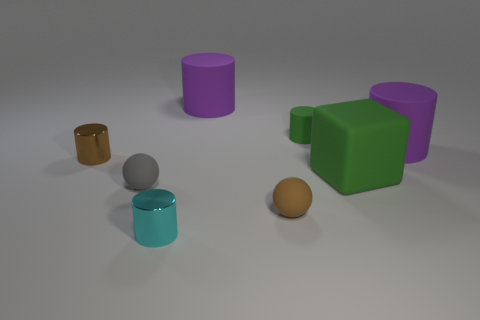Add 2 small balls. How many objects exist? 10 Subtract all tiny rubber cylinders. How many cylinders are left? 4 Subtract 1 cylinders. How many cylinders are left? 4 Subtract all gray spheres. How many spheres are left? 1 Subtract all red cylinders. Subtract all red spheres. How many cylinders are left? 5 Subtract all green spheres. How many green cylinders are left? 1 Subtract all small matte spheres. Subtract all small metal cylinders. How many objects are left? 4 Add 2 tiny green objects. How many tiny green objects are left? 3 Add 8 green matte objects. How many green matte objects exist? 10 Subtract 1 gray balls. How many objects are left? 7 